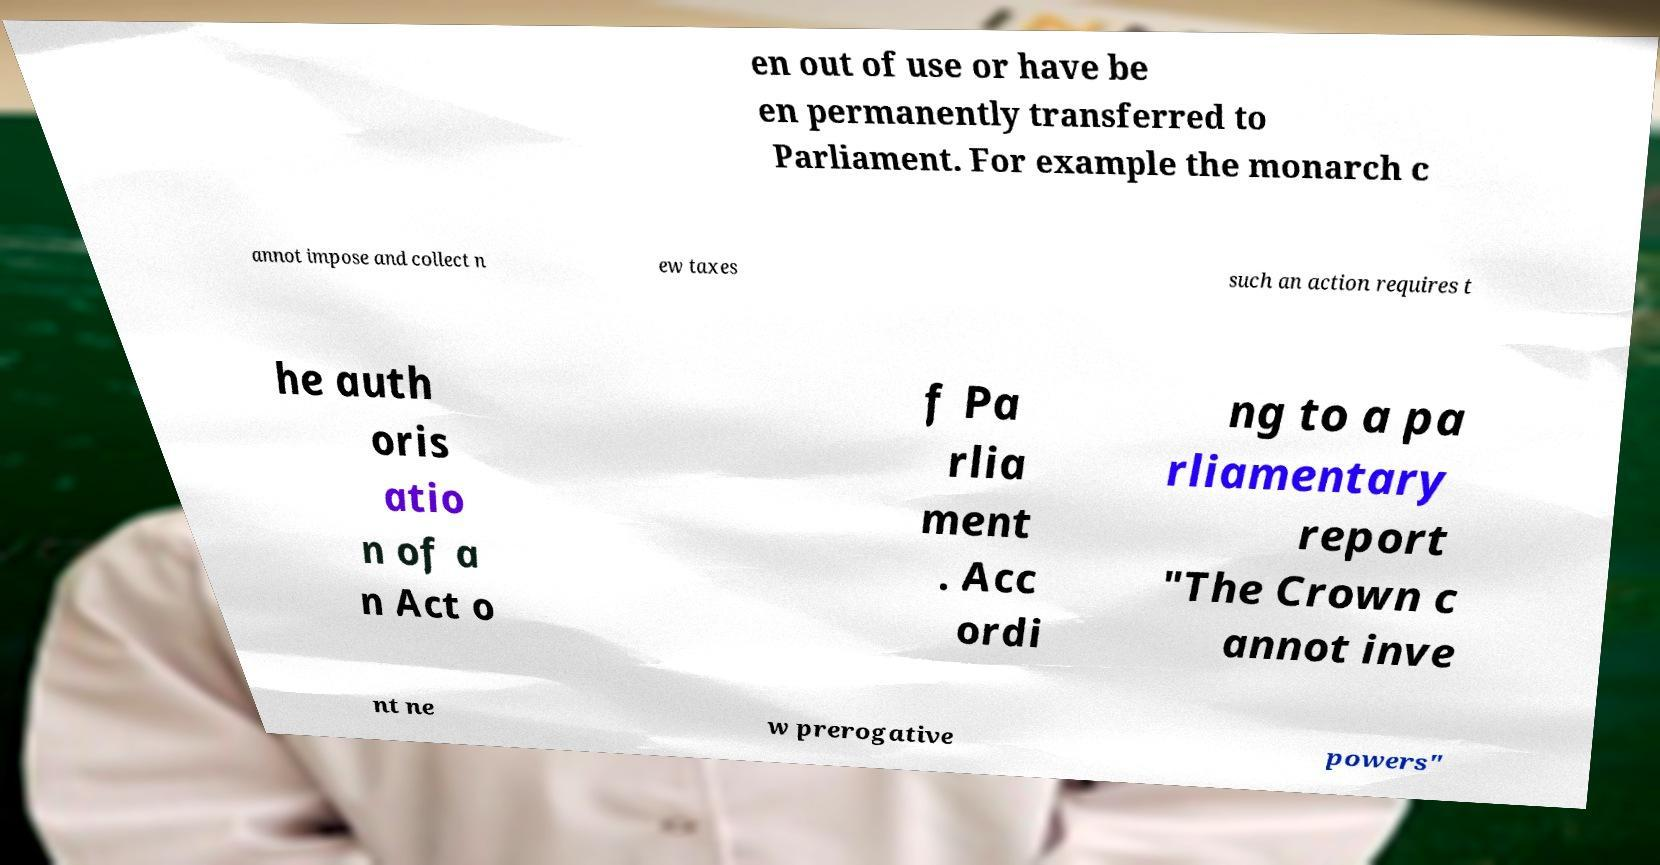What messages or text are displayed in this image? I need them in a readable, typed format. en out of use or have be en permanently transferred to Parliament. For example the monarch c annot impose and collect n ew taxes such an action requires t he auth oris atio n of a n Act o f Pa rlia ment . Acc ordi ng to a pa rliamentary report "The Crown c annot inve nt ne w prerogative powers" 